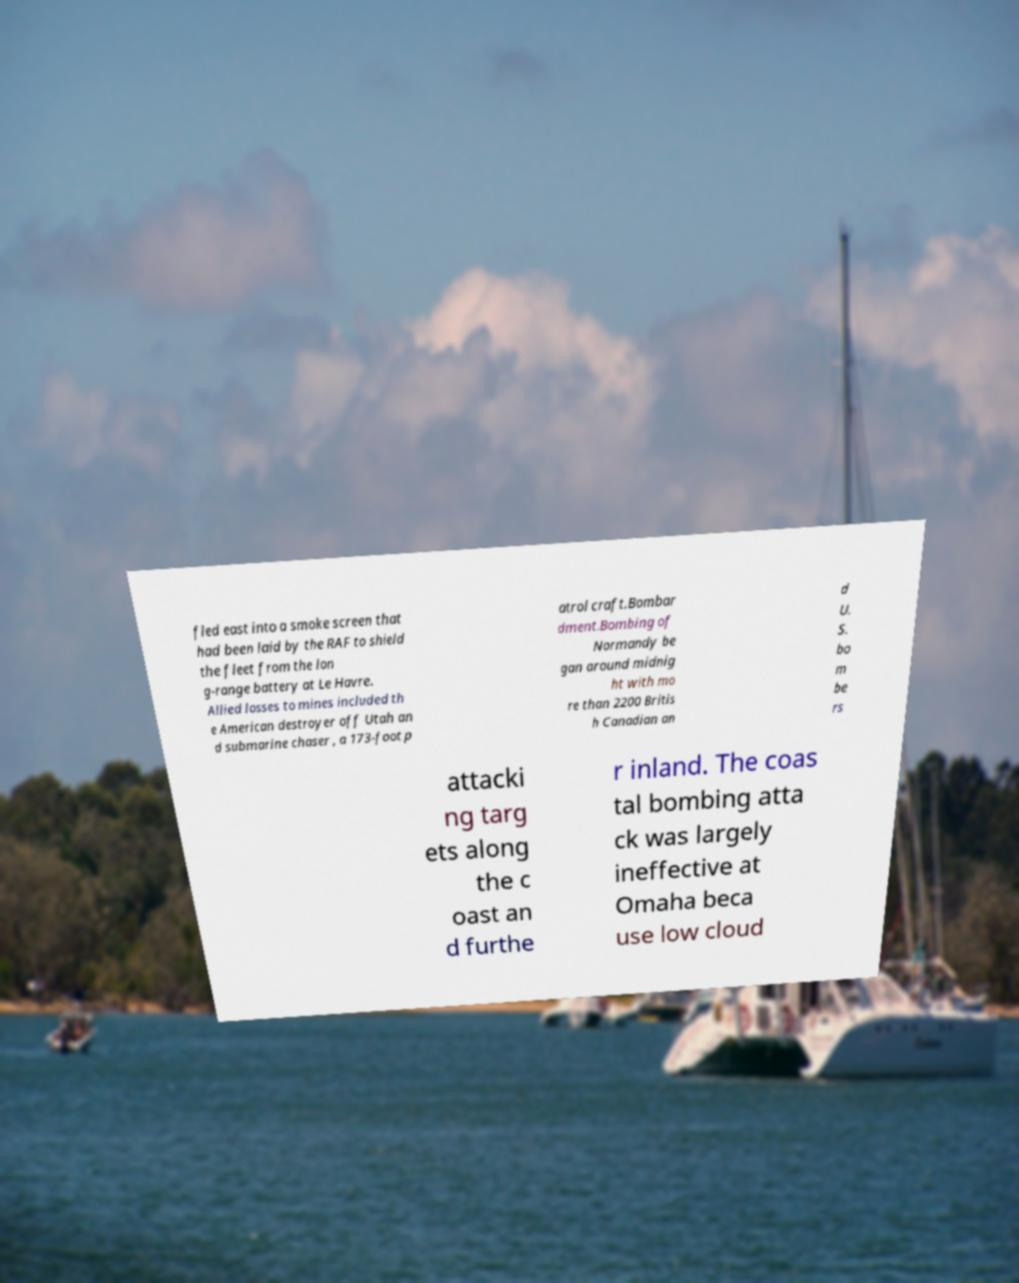There's text embedded in this image that I need extracted. Can you transcribe it verbatim? fled east into a smoke screen that had been laid by the RAF to shield the fleet from the lon g-range battery at Le Havre. Allied losses to mines included th e American destroyer off Utah an d submarine chaser , a 173-foot p atrol craft.Bombar dment.Bombing of Normandy be gan around midnig ht with mo re than 2200 Britis h Canadian an d U. S. bo m be rs attacki ng targ ets along the c oast an d furthe r inland. The coas tal bombing atta ck was largely ineffective at Omaha beca use low cloud 